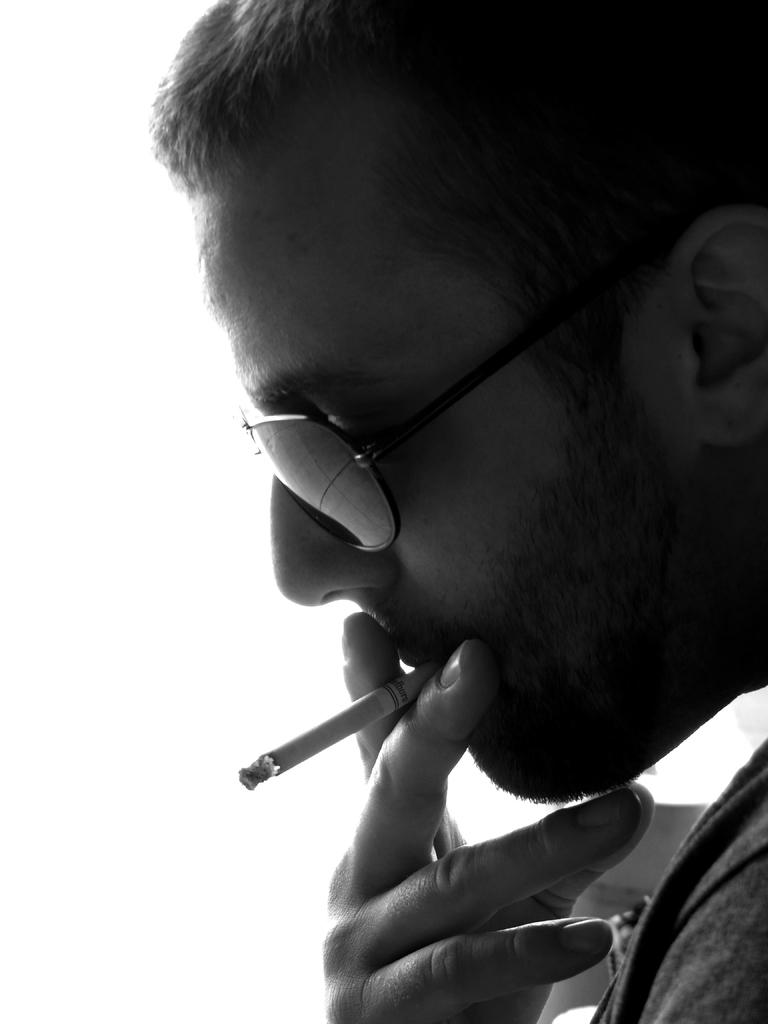Who is present in the image? There is a man in the image. What is the man doing in the image? The man is smoking in the image. What accessory is the man wearing in the image? The man is wearing glasses in the image. What is the color of the background in the image? The background of the image is white. How many tomatoes are on the van in the image? There is no van or tomatoes present in the image; it features a man smoking and wearing glasses against a white background. Is there a woman in the image? No, there is no woman present in the image; it features a man smoking and wearing glasses against a white background. 